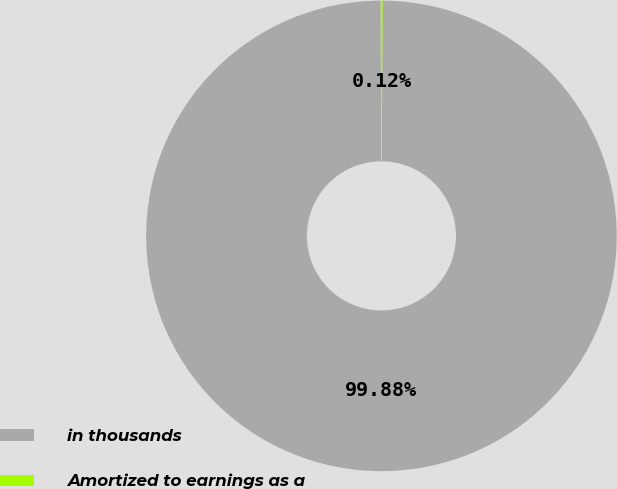Convert chart. <chart><loc_0><loc_0><loc_500><loc_500><pie_chart><fcel>in thousands<fcel>Amortized to earnings as a<nl><fcel>99.88%<fcel>0.12%<nl></chart> 